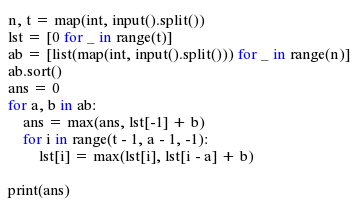Convert code to text. <code><loc_0><loc_0><loc_500><loc_500><_Python_>n, t = map(int, input().split())
lst = [0 for _ in range(t)]
ab = [list(map(int, input().split())) for _ in range(n)]
ab.sort()
ans = 0
for a, b in ab:
    ans = max(ans, lst[-1] + b)
    for i in range(t - 1, a - 1, -1):
        lst[i] = max(lst[i], lst[i - a] + b)

print(ans)</code> 